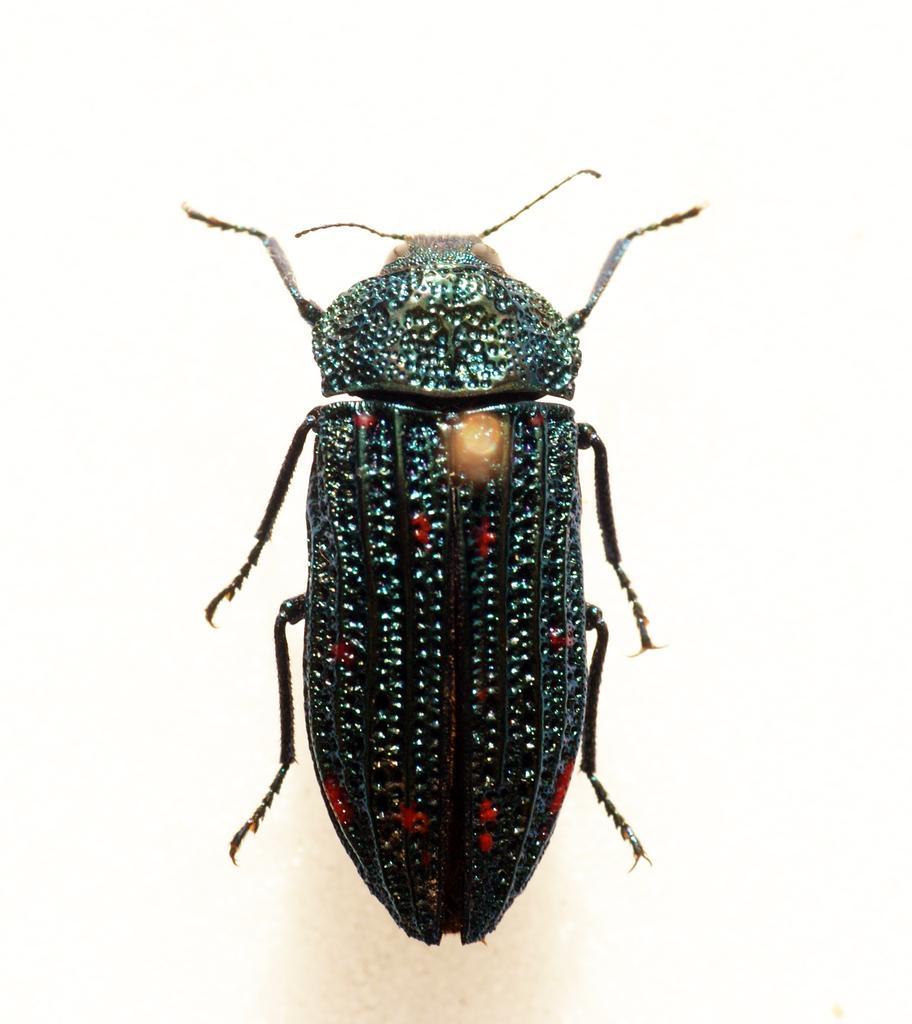How would you summarize this image in a sentence or two? There is an insect which is black in color is having six legs and two antennas. In the background, it is white in color. 